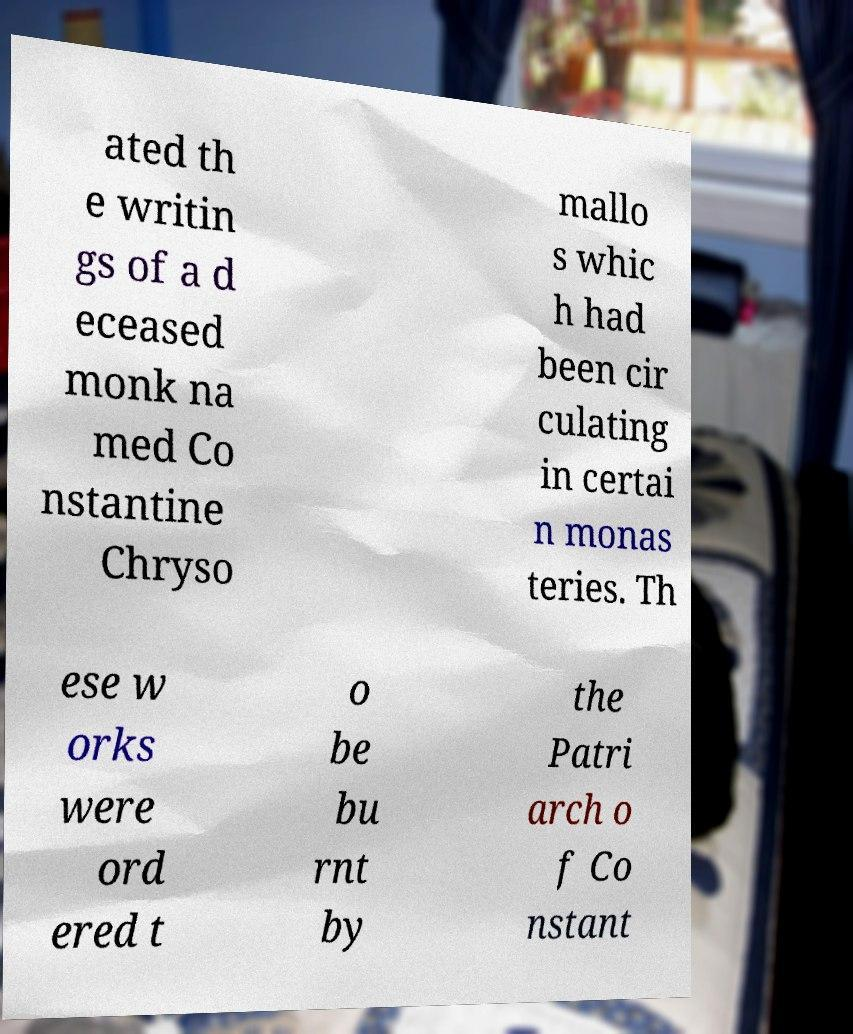What messages or text are displayed in this image? I need them in a readable, typed format. ated th e writin gs of a d eceased monk na med Co nstantine Chryso mallo s whic h had been cir culating in certai n monas teries. Th ese w orks were ord ered t o be bu rnt by the Patri arch o f Co nstant 